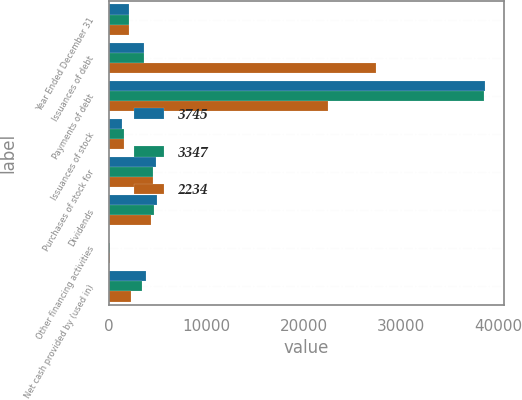<chart> <loc_0><loc_0><loc_500><loc_500><stacked_bar_chart><ecel><fcel>Year Ended December 31<fcel>Issuances of debt<fcel>Payments of debt<fcel>Issuances of stock<fcel>Purchases of stock for<fcel>Dividends<fcel>Other financing activities<fcel>Net cash provided by (used in)<nl><fcel>3745<fcel>2013<fcel>3546<fcel>38714<fcel>1328<fcel>4832<fcel>4969<fcel>17<fcel>3745<nl><fcel>3347<fcel>2012<fcel>3546<fcel>38573<fcel>1489<fcel>4559<fcel>4595<fcel>100<fcel>3347<nl><fcel>2234<fcel>2011<fcel>27495<fcel>22530<fcel>1569<fcel>4513<fcel>4300<fcel>45<fcel>2234<nl></chart> 